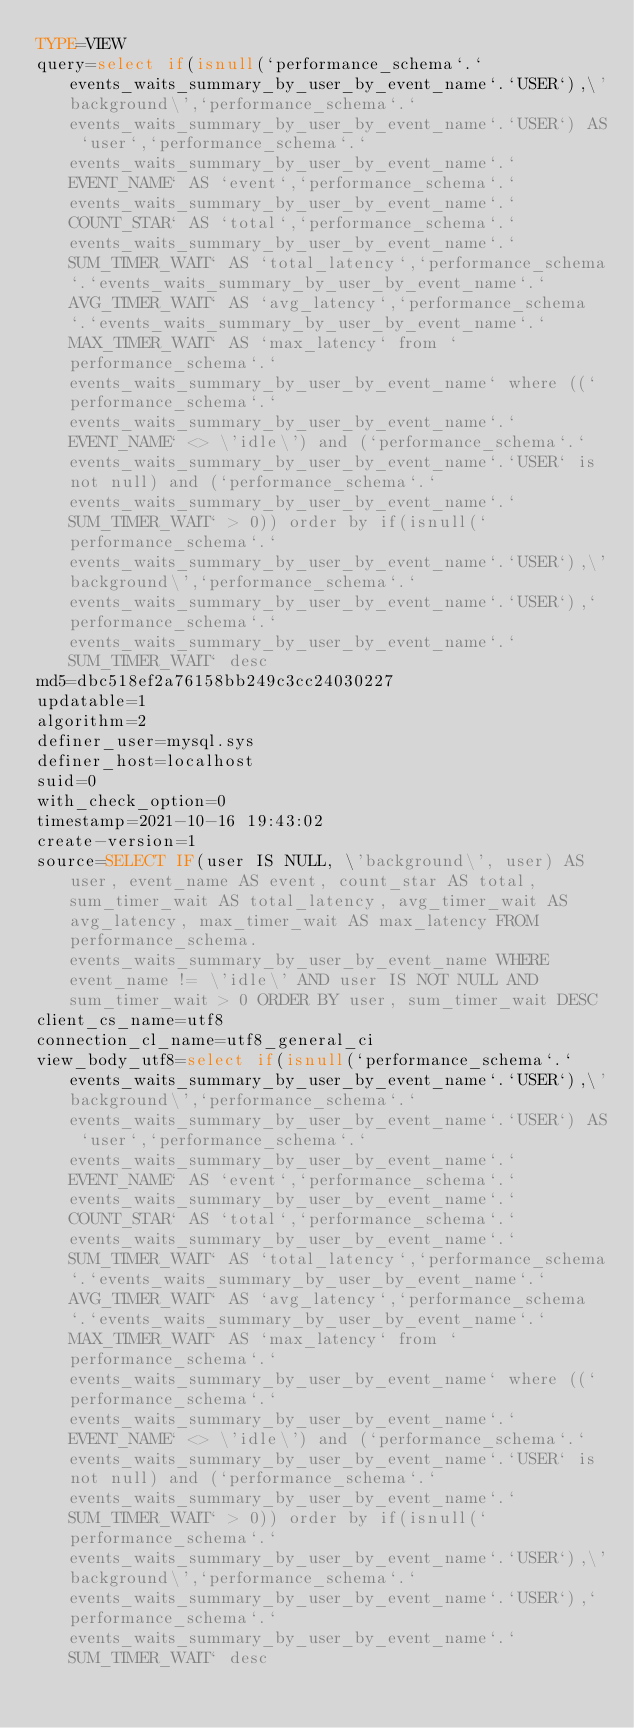<code> <loc_0><loc_0><loc_500><loc_500><_VisualBasic_>TYPE=VIEW
query=select if(isnull(`performance_schema`.`events_waits_summary_by_user_by_event_name`.`USER`),\'background\',`performance_schema`.`events_waits_summary_by_user_by_event_name`.`USER`) AS `user`,`performance_schema`.`events_waits_summary_by_user_by_event_name`.`EVENT_NAME` AS `event`,`performance_schema`.`events_waits_summary_by_user_by_event_name`.`COUNT_STAR` AS `total`,`performance_schema`.`events_waits_summary_by_user_by_event_name`.`SUM_TIMER_WAIT` AS `total_latency`,`performance_schema`.`events_waits_summary_by_user_by_event_name`.`AVG_TIMER_WAIT` AS `avg_latency`,`performance_schema`.`events_waits_summary_by_user_by_event_name`.`MAX_TIMER_WAIT` AS `max_latency` from `performance_schema`.`events_waits_summary_by_user_by_event_name` where ((`performance_schema`.`events_waits_summary_by_user_by_event_name`.`EVENT_NAME` <> \'idle\') and (`performance_schema`.`events_waits_summary_by_user_by_event_name`.`USER` is not null) and (`performance_schema`.`events_waits_summary_by_user_by_event_name`.`SUM_TIMER_WAIT` > 0)) order by if(isnull(`performance_schema`.`events_waits_summary_by_user_by_event_name`.`USER`),\'background\',`performance_schema`.`events_waits_summary_by_user_by_event_name`.`USER`),`performance_schema`.`events_waits_summary_by_user_by_event_name`.`SUM_TIMER_WAIT` desc
md5=dbc518ef2a76158bb249c3cc24030227
updatable=1
algorithm=2
definer_user=mysql.sys
definer_host=localhost
suid=0
with_check_option=0
timestamp=2021-10-16 19:43:02
create-version=1
source=SELECT IF(user IS NULL, \'background\', user) AS user, event_name AS event, count_star AS total, sum_timer_wait AS total_latency, avg_timer_wait AS avg_latency, max_timer_wait AS max_latency FROM performance_schema.events_waits_summary_by_user_by_event_name WHERE event_name != \'idle\' AND user IS NOT NULL AND sum_timer_wait > 0 ORDER BY user, sum_timer_wait DESC
client_cs_name=utf8
connection_cl_name=utf8_general_ci
view_body_utf8=select if(isnull(`performance_schema`.`events_waits_summary_by_user_by_event_name`.`USER`),\'background\',`performance_schema`.`events_waits_summary_by_user_by_event_name`.`USER`) AS `user`,`performance_schema`.`events_waits_summary_by_user_by_event_name`.`EVENT_NAME` AS `event`,`performance_schema`.`events_waits_summary_by_user_by_event_name`.`COUNT_STAR` AS `total`,`performance_schema`.`events_waits_summary_by_user_by_event_name`.`SUM_TIMER_WAIT` AS `total_latency`,`performance_schema`.`events_waits_summary_by_user_by_event_name`.`AVG_TIMER_WAIT` AS `avg_latency`,`performance_schema`.`events_waits_summary_by_user_by_event_name`.`MAX_TIMER_WAIT` AS `max_latency` from `performance_schema`.`events_waits_summary_by_user_by_event_name` where ((`performance_schema`.`events_waits_summary_by_user_by_event_name`.`EVENT_NAME` <> \'idle\') and (`performance_schema`.`events_waits_summary_by_user_by_event_name`.`USER` is not null) and (`performance_schema`.`events_waits_summary_by_user_by_event_name`.`SUM_TIMER_WAIT` > 0)) order by if(isnull(`performance_schema`.`events_waits_summary_by_user_by_event_name`.`USER`),\'background\',`performance_schema`.`events_waits_summary_by_user_by_event_name`.`USER`),`performance_schema`.`events_waits_summary_by_user_by_event_name`.`SUM_TIMER_WAIT` desc
</code> 